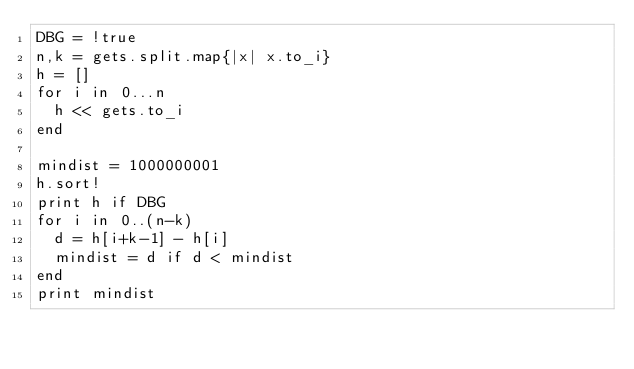<code> <loc_0><loc_0><loc_500><loc_500><_Ruby_>DBG = !true
n,k = gets.split.map{|x| x.to_i}
h = []
for i in 0...n
  h << gets.to_i
end

mindist = 1000000001
h.sort!
print h if DBG
for i in 0..(n-k)
  d = h[i+k-1] - h[i]
  mindist = d if d < mindist
end
print mindist
</code> 